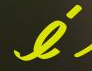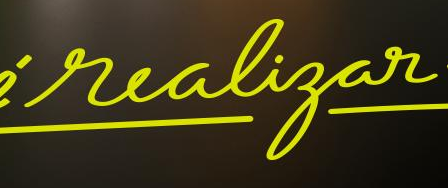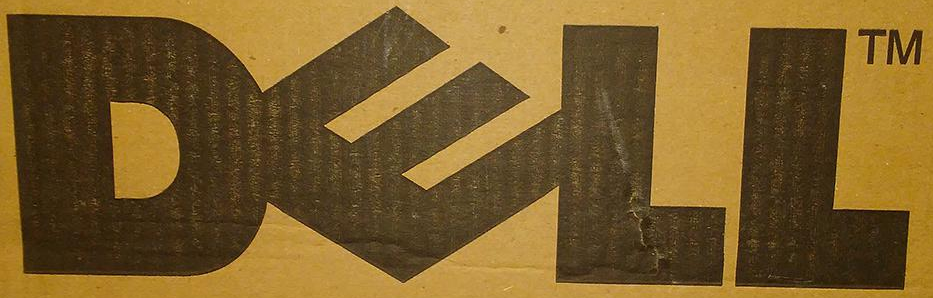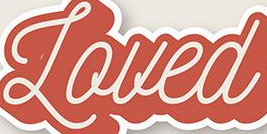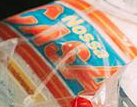What words can you see in these images in sequence, separated by a semicolon? é; realigar; DELL; Loued; CASA 